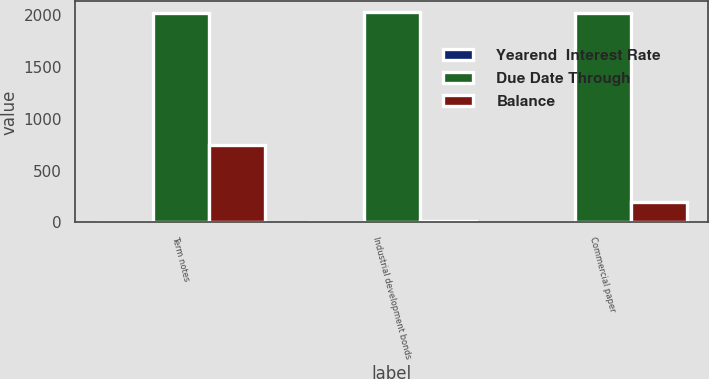Convert chart. <chart><loc_0><loc_0><loc_500><loc_500><stacked_bar_chart><ecel><fcel>Term notes<fcel>Industrial development bonds<fcel>Commercial paper<nl><fcel>Yearend  Interest Rate<fcel>3.8<fcel>0.9<fcel>1<nl><fcel>Due Date Through<fcel>2024<fcel>2030<fcel>2021<nl><fcel>Balance<fcel>745.3<fcel>12.5<fcel>195.9<nl></chart> 